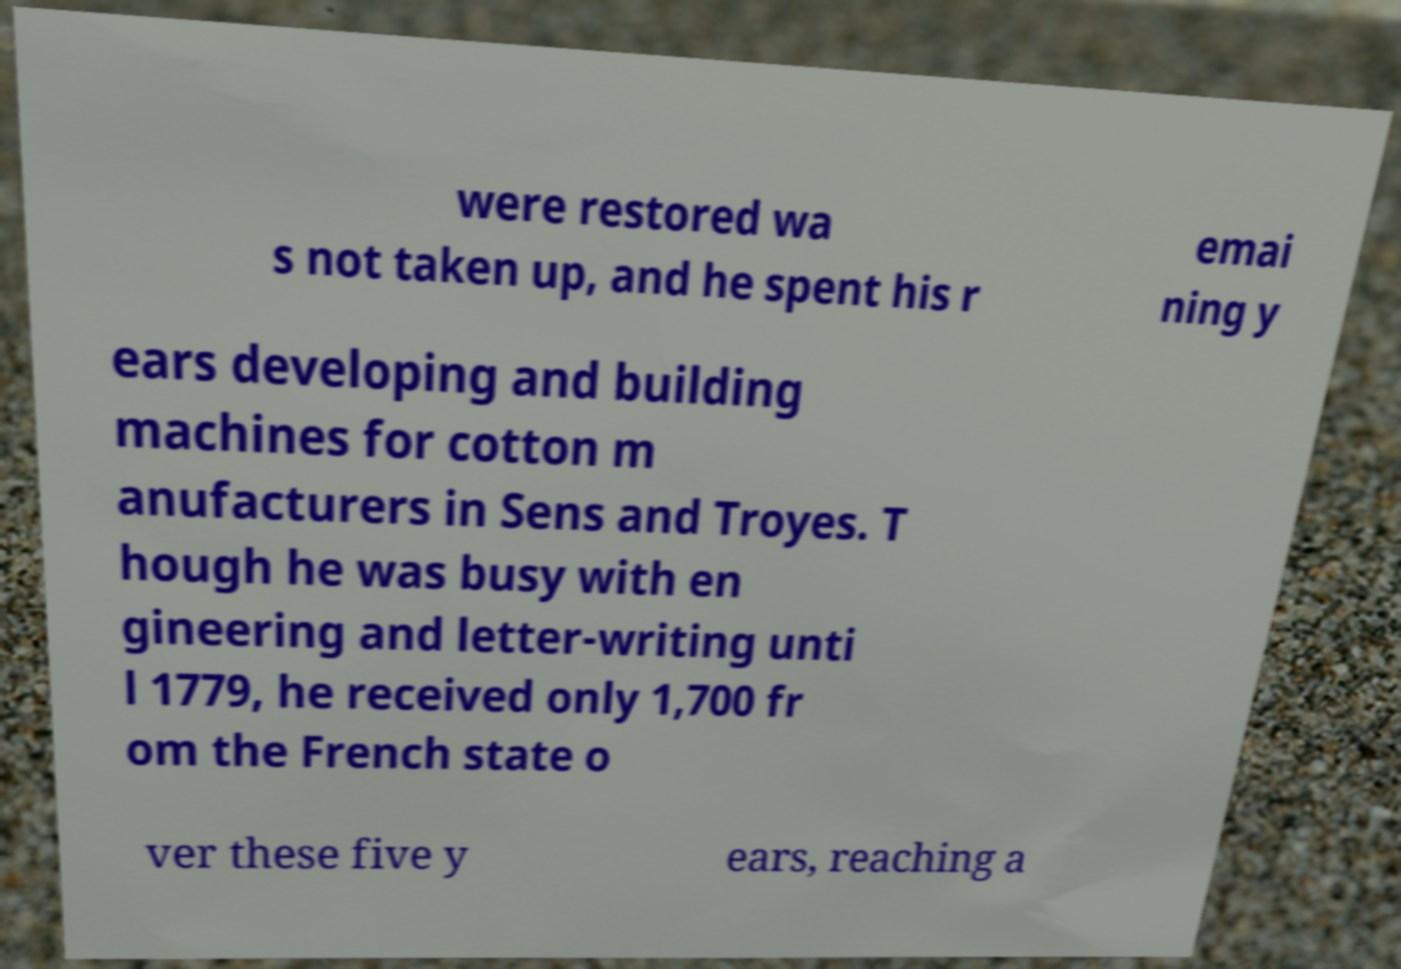There's text embedded in this image that I need extracted. Can you transcribe it verbatim? were restored wa s not taken up, and he spent his r emai ning y ears developing and building machines for cotton m anufacturers in Sens and Troyes. T hough he was busy with en gineering and letter-writing unti l 1779, he received only 1,700 fr om the French state o ver these five y ears, reaching a 